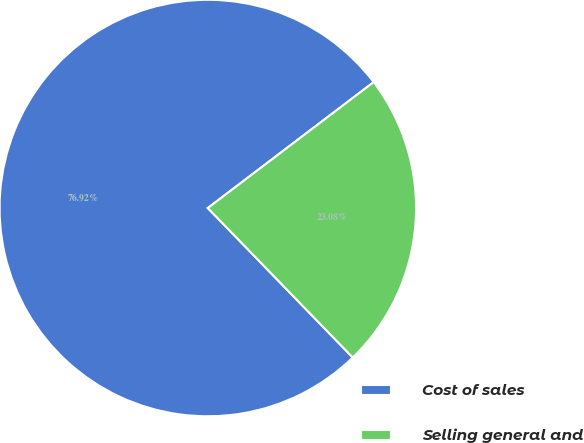<chart> <loc_0><loc_0><loc_500><loc_500><pie_chart><fcel>Cost of sales<fcel>Selling general and<nl><fcel>76.92%<fcel>23.08%<nl></chart> 